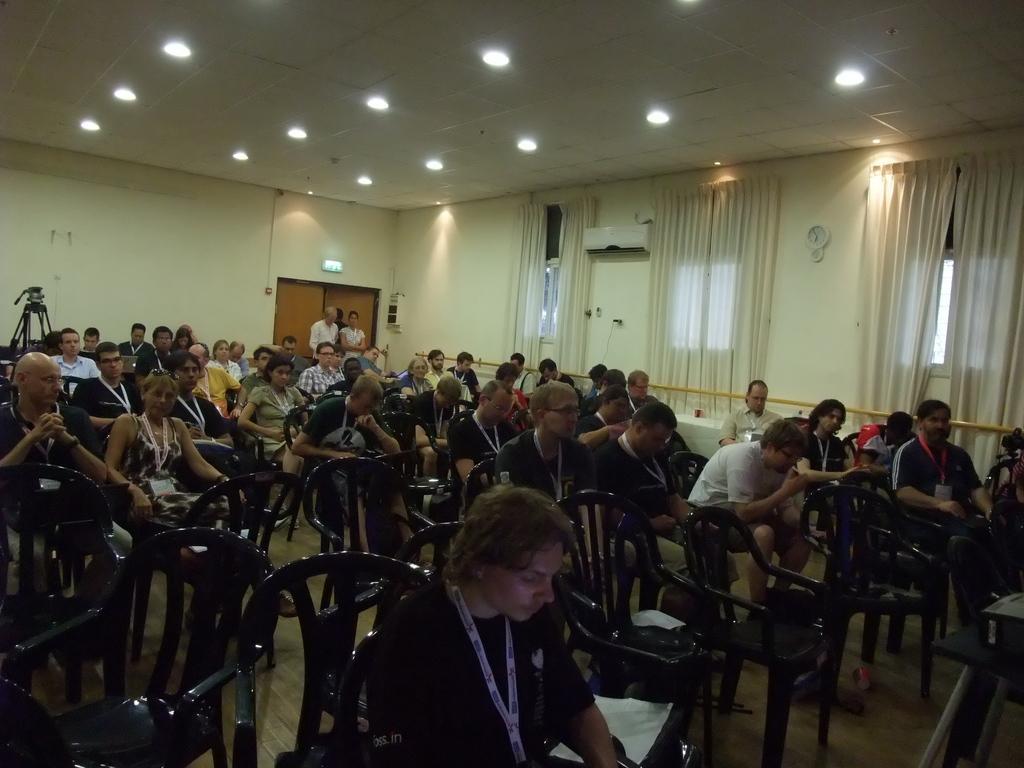Could you give a brief overview of what you see in this image? In the image I can see some people sitting on the chairs and around there are some curtains and some lights to the roof. 